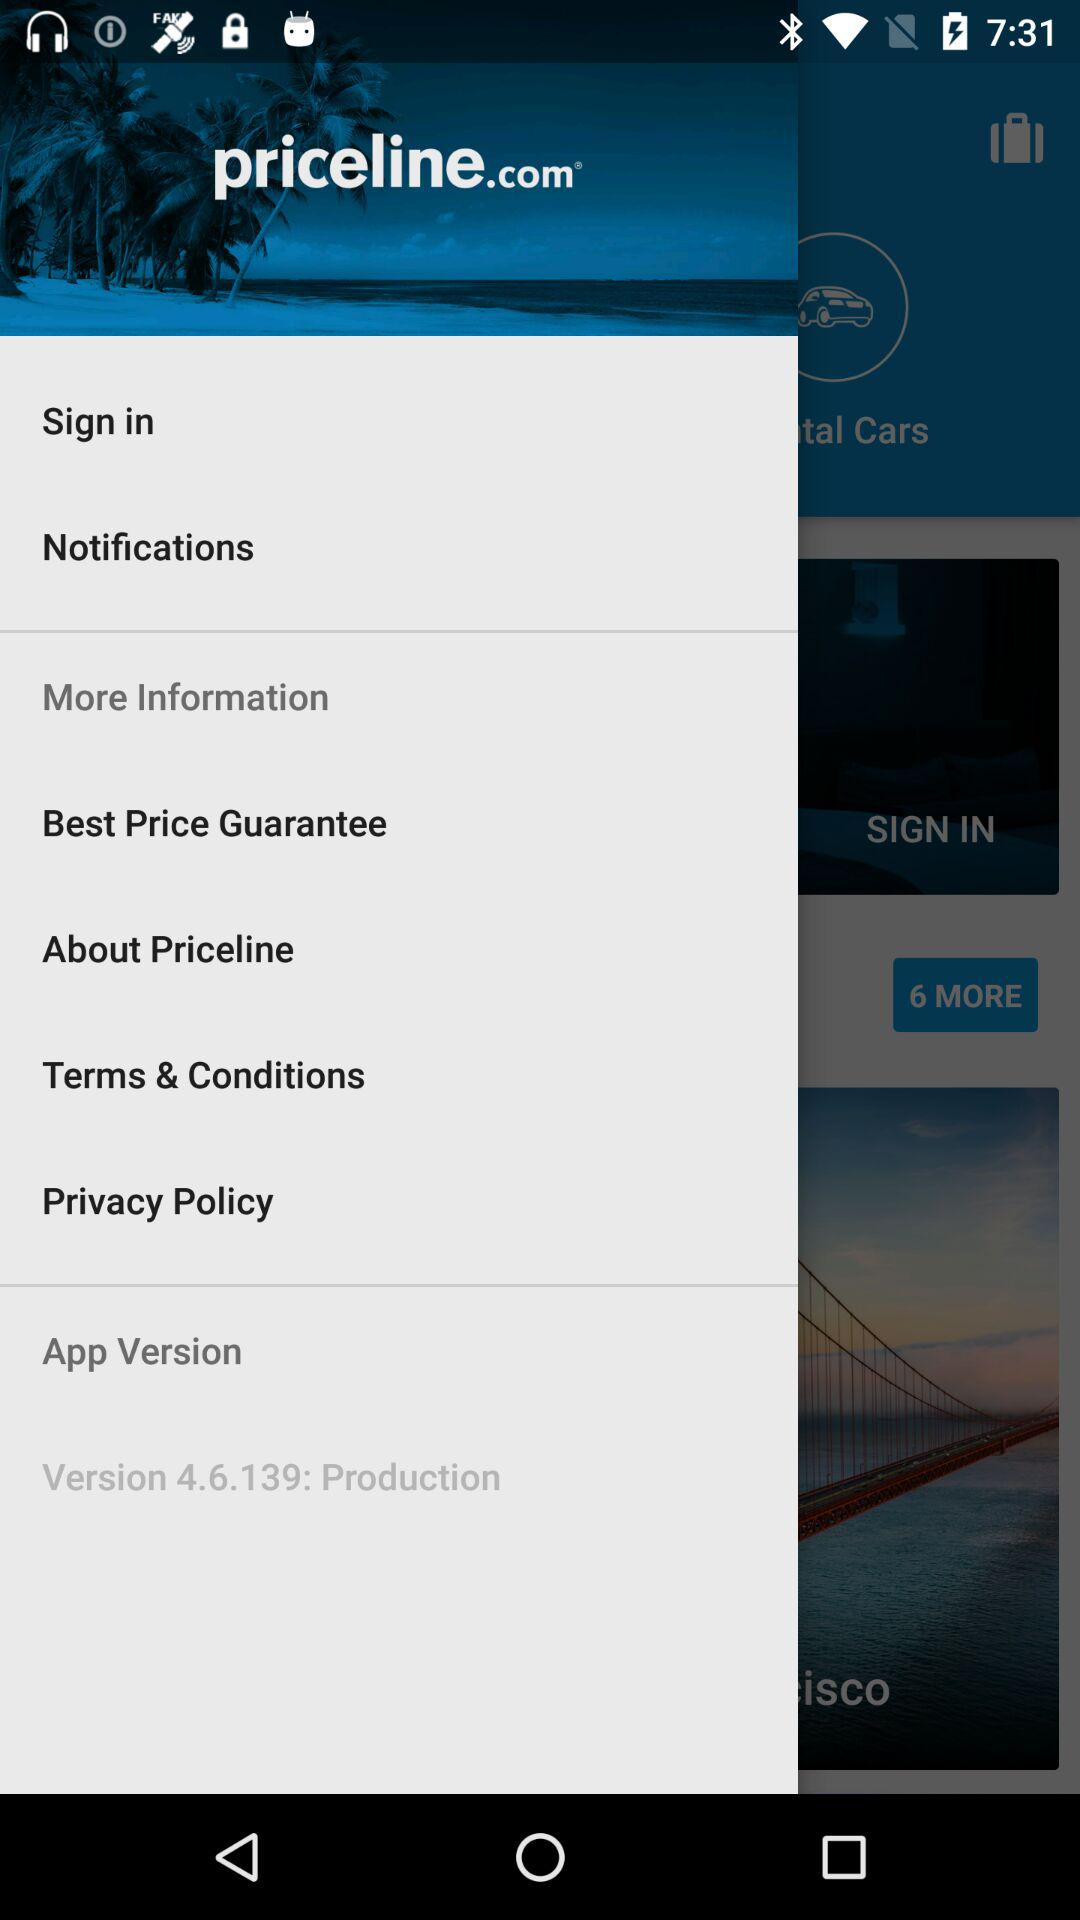What is the developer name? The developer name is priceline.com. 